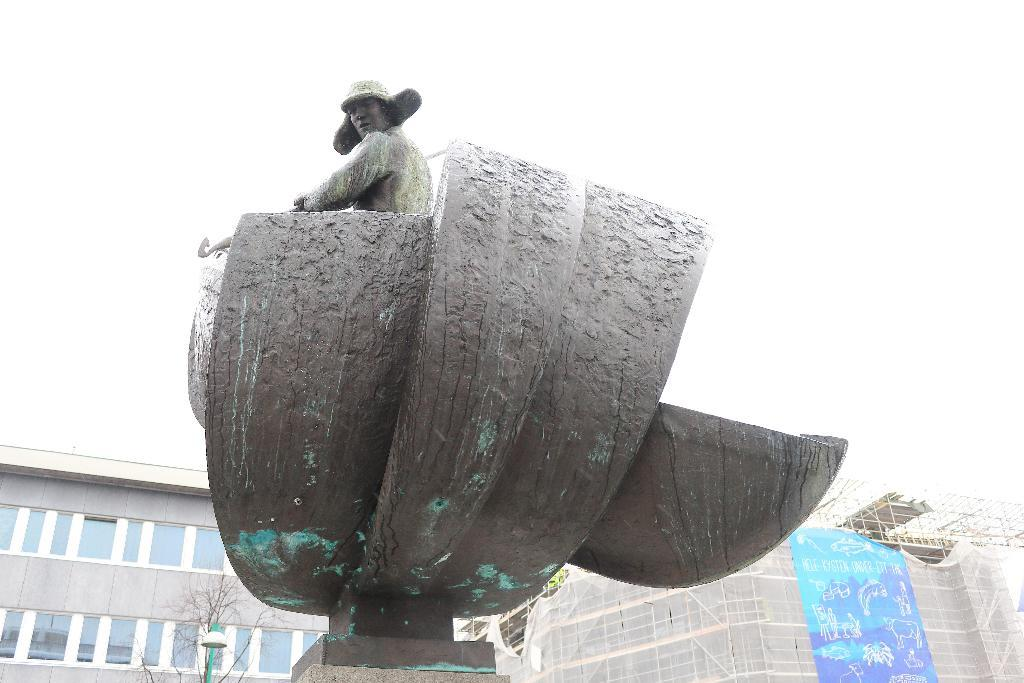What type of structures can be seen in the background of the image? There are buildings in the background of the image. What natural element is present in the background of the image? There is a bare tree in the background of the image. What type of lighting is present in the background of the image? There is a light with a pole in the background of the image. What color is the banner in the image? The banner in the image is blue. What type of figure is depicted in the image? There is a statue of a man in the image. Can you describe the fight between the two men in the image? There is no fight between two men depicted in the image; it features a statue of a man and other elements mentioned in the facts. What is the relation between the man and the woman in the image? There is no woman present in the image, only a statue of a man and other elements mentioned in the facts. 